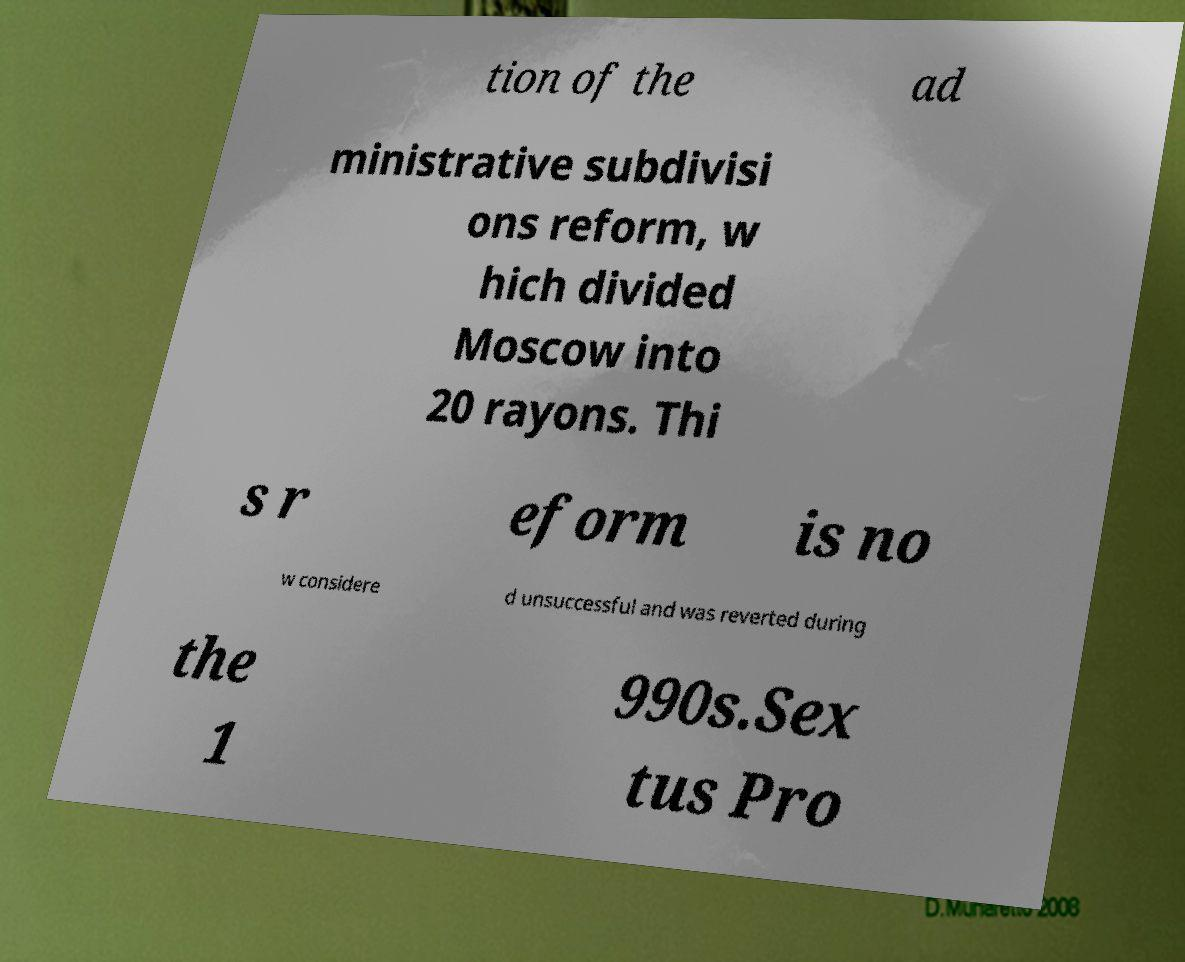Please read and relay the text visible in this image. What does it say? tion of the ad ministrative subdivisi ons reform, w hich divided Moscow into 20 rayons. Thi s r eform is no w considere d unsuccessful and was reverted during the 1 990s.Sex tus Pro 